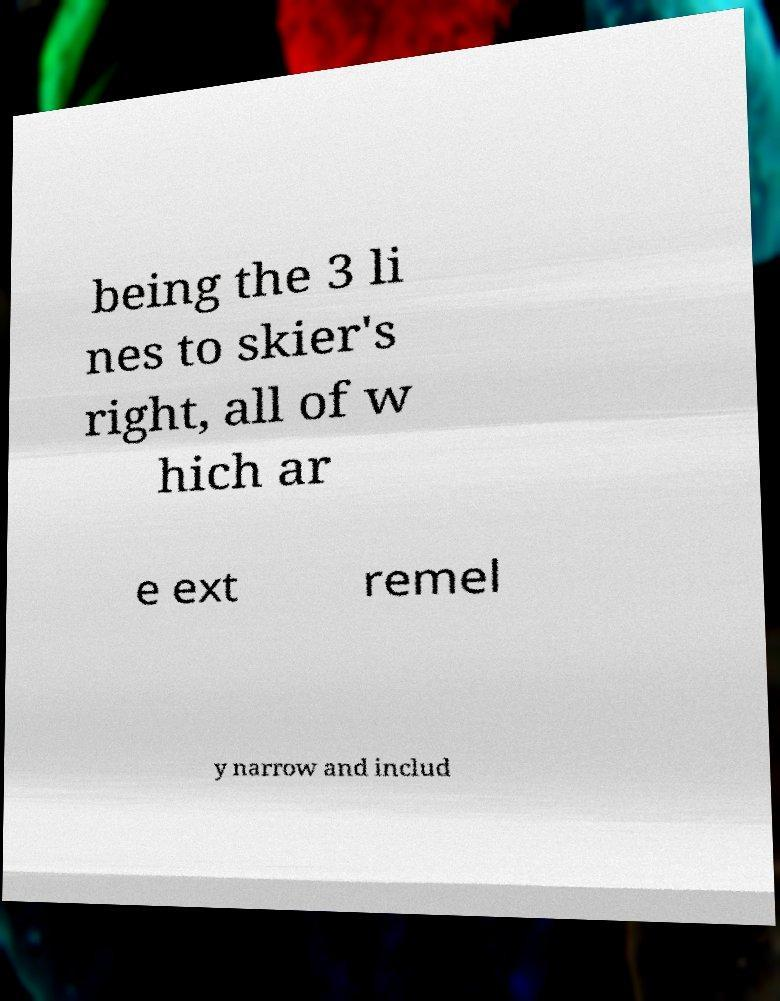Could you assist in decoding the text presented in this image and type it out clearly? being the 3 li nes to skier's right, all of w hich ar e ext remel y narrow and includ 